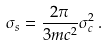<formula> <loc_0><loc_0><loc_500><loc_500>\sigma _ { s } = \frac { 2 \pi } { 3 m c ^ { 2 } } \sigma _ { c } ^ { 2 } \, .</formula> 